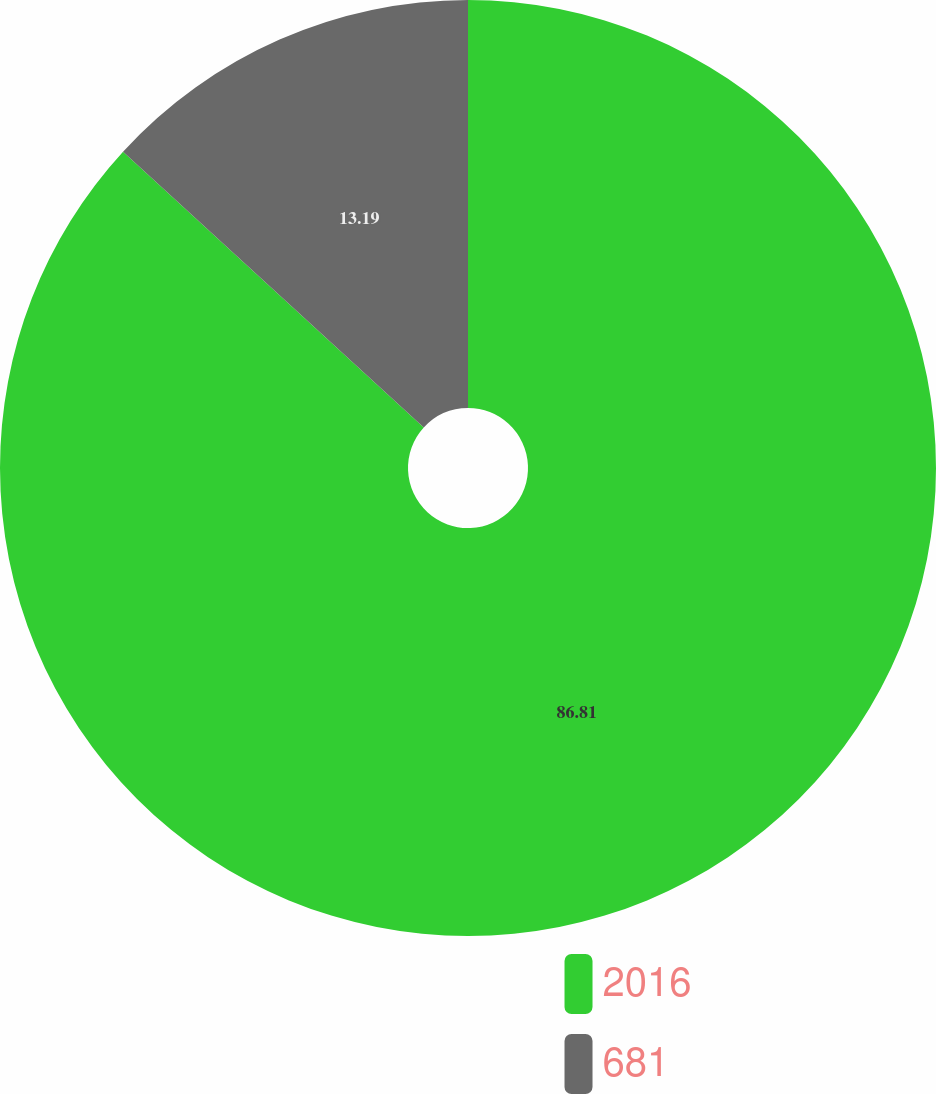Convert chart to OTSL. <chart><loc_0><loc_0><loc_500><loc_500><pie_chart><fcel>2016<fcel>681<nl><fcel>86.81%<fcel>13.19%<nl></chart> 